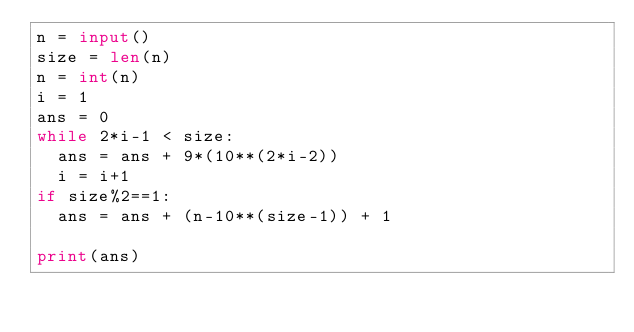<code> <loc_0><loc_0><loc_500><loc_500><_Python_>n = input()
size = len(n)
n = int(n)
i = 1
ans = 0
while 2*i-1 < size:
  ans = ans + 9*(10**(2*i-2))
  i = i+1
if size%2==1:
  ans = ans + (n-10**(size-1)) + 1
  
print(ans)</code> 